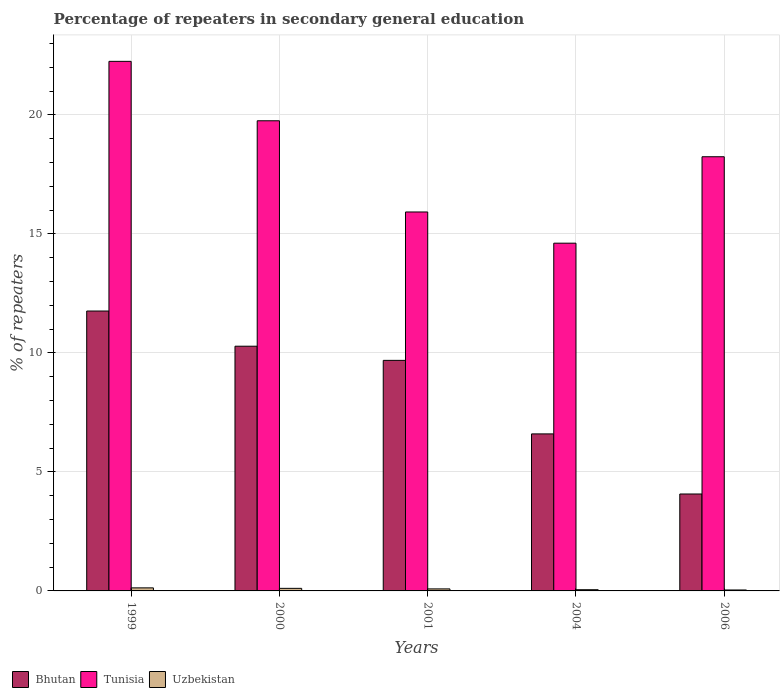Are the number of bars per tick equal to the number of legend labels?
Give a very brief answer. Yes. How many bars are there on the 2nd tick from the left?
Your response must be concise. 3. In how many cases, is the number of bars for a given year not equal to the number of legend labels?
Your response must be concise. 0. What is the percentage of repeaters in secondary general education in Uzbekistan in 2000?
Provide a succinct answer. 0.11. Across all years, what is the maximum percentage of repeaters in secondary general education in Tunisia?
Provide a short and direct response. 22.25. Across all years, what is the minimum percentage of repeaters in secondary general education in Bhutan?
Ensure brevity in your answer.  4.07. In which year was the percentage of repeaters in secondary general education in Bhutan maximum?
Provide a succinct answer. 1999. In which year was the percentage of repeaters in secondary general education in Uzbekistan minimum?
Make the answer very short. 2006. What is the total percentage of repeaters in secondary general education in Tunisia in the graph?
Provide a succinct answer. 90.77. What is the difference between the percentage of repeaters in secondary general education in Tunisia in 1999 and that in 2000?
Ensure brevity in your answer.  2.5. What is the difference between the percentage of repeaters in secondary general education in Tunisia in 2001 and the percentage of repeaters in secondary general education in Bhutan in 1999?
Provide a succinct answer. 4.16. What is the average percentage of repeaters in secondary general education in Tunisia per year?
Provide a succinct answer. 18.15. In the year 2006, what is the difference between the percentage of repeaters in secondary general education in Tunisia and percentage of repeaters in secondary general education in Bhutan?
Give a very brief answer. 14.17. In how many years, is the percentage of repeaters in secondary general education in Tunisia greater than 3 %?
Make the answer very short. 5. What is the ratio of the percentage of repeaters in secondary general education in Uzbekistan in 2001 to that in 2006?
Give a very brief answer. 2.16. Is the difference between the percentage of repeaters in secondary general education in Tunisia in 2004 and 2006 greater than the difference between the percentage of repeaters in secondary general education in Bhutan in 2004 and 2006?
Offer a terse response. No. What is the difference between the highest and the second highest percentage of repeaters in secondary general education in Tunisia?
Your answer should be compact. 2.5. What is the difference between the highest and the lowest percentage of repeaters in secondary general education in Uzbekistan?
Ensure brevity in your answer.  0.09. What does the 3rd bar from the left in 2004 represents?
Make the answer very short. Uzbekistan. What does the 1st bar from the right in 1999 represents?
Provide a short and direct response. Uzbekistan. Is it the case that in every year, the sum of the percentage of repeaters in secondary general education in Uzbekistan and percentage of repeaters in secondary general education in Bhutan is greater than the percentage of repeaters in secondary general education in Tunisia?
Offer a terse response. No. Does the graph contain any zero values?
Your answer should be compact. No. Does the graph contain grids?
Offer a very short reply. Yes. How many legend labels are there?
Offer a very short reply. 3. How are the legend labels stacked?
Give a very brief answer. Horizontal. What is the title of the graph?
Ensure brevity in your answer.  Percentage of repeaters in secondary general education. Does "Liechtenstein" appear as one of the legend labels in the graph?
Your answer should be compact. No. What is the label or title of the X-axis?
Your answer should be compact. Years. What is the label or title of the Y-axis?
Offer a very short reply. % of repeaters. What is the % of repeaters in Bhutan in 1999?
Make the answer very short. 11.76. What is the % of repeaters of Tunisia in 1999?
Make the answer very short. 22.25. What is the % of repeaters of Uzbekistan in 1999?
Make the answer very short. 0.13. What is the % of repeaters in Bhutan in 2000?
Offer a terse response. 10.28. What is the % of repeaters in Tunisia in 2000?
Ensure brevity in your answer.  19.75. What is the % of repeaters of Uzbekistan in 2000?
Your answer should be very brief. 0.11. What is the % of repeaters in Bhutan in 2001?
Your answer should be very brief. 9.69. What is the % of repeaters in Tunisia in 2001?
Offer a very short reply. 15.92. What is the % of repeaters in Uzbekistan in 2001?
Provide a short and direct response. 0.09. What is the % of repeaters of Bhutan in 2004?
Offer a very short reply. 6.6. What is the % of repeaters in Tunisia in 2004?
Offer a terse response. 14.61. What is the % of repeaters in Uzbekistan in 2004?
Your answer should be very brief. 0.05. What is the % of repeaters in Bhutan in 2006?
Your answer should be very brief. 4.07. What is the % of repeaters in Tunisia in 2006?
Make the answer very short. 18.24. What is the % of repeaters in Uzbekistan in 2006?
Your answer should be compact. 0.04. Across all years, what is the maximum % of repeaters in Bhutan?
Keep it short and to the point. 11.76. Across all years, what is the maximum % of repeaters in Tunisia?
Your response must be concise. 22.25. Across all years, what is the maximum % of repeaters in Uzbekistan?
Offer a terse response. 0.13. Across all years, what is the minimum % of repeaters in Bhutan?
Offer a terse response. 4.07. Across all years, what is the minimum % of repeaters of Tunisia?
Offer a terse response. 14.61. Across all years, what is the minimum % of repeaters of Uzbekistan?
Your answer should be very brief. 0.04. What is the total % of repeaters in Bhutan in the graph?
Your answer should be compact. 42.39. What is the total % of repeaters of Tunisia in the graph?
Offer a terse response. 90.77. What is the total % of repeaters in Uzbekistan in the graph?
Make the answer very short. 0.41. What is the difference between the % of repeaters in Bhutan in 1999 and that in 2000?
Your answer should be compact. 1.48. What is the difference between the % of repeaters in Tunisia in 1999 and that in 2000?
Ensure brevity in your answer.  2.5. What is the difference between the % of repeaters in Uzbekistan in 1999 and that in 2000?
Your answer should be very brief. 0.02. What is the difference between the % of repeaters in Bhutan in 1999 and that in 2001?
Keep it short and to the point. 2.07. What is the difference between the % of repeaters in Tunisia in 1999 and that in 2001?
Your response must be concise. 6.33. What is the difference between the % of repeaters of Uzbekistan in 1999 and that in 2001?
Make the answer very short. 0.04. What is the difference between the % of repeaters in Bhutan in 1999 and that in 2004?
Your answer should be compact. 5.16. What is the difference between the % of repeaters in Tunisia in 1999 and that in 2004?
Your answer should be very brief. 7.64. What is the difference between the % of repeaters of Uzbekistan in 1999 and that in 2004?
Ensure brevity in your answer.  0.08. What is the difference between the % of repeaters in Bhutan in 1999 and that in 2006?
Your answer should be compact. 7.69. What is the difference between the % of repeaters in Tunisia in 1999 and that in 2006?
Your answer should be compact. 4.01. What is the difference between the % of repeaters of Uzbekistan in 1999 and that in 2006?
Ensure brevity in your answer.  0.09. What is the difference between the % of repeaters in Bhutan in 2000 and that in 2001?
Your response must be concise. 0.6. What is the difference between the % of repeaters of Tunisia in 2000 and that in 2001?
Keep it short and to the point. 3.83. What is the difference between the % of repeaters in Uzbekistan in 2000 and that in 2001?
Provide a short and direct response. 0.02. What is the difference between the % of repeaters of Bhutan in 2000 and that in 2004?
Your answer should be compact. 3.68. What is the difference between the % of repeaters of Tunisia in 2000 and that in 2004?
Your answer should be very brief. 5.14. What is the difference between the % of repeaters of Uzbekistan in 2000 and that in 2004?
Your response must be concise. 0.06. What is the difference between the % of repeaters of Bhutan in 2000 and that in 2006?
Your response must be concise. 6.21. What is the difference between the % of repeaters in Tunisia in 2000 and that in 2006?
Offer a terse response. 1.51. What is the difference between the % of repeaters in Uzbekistan in 2000 and that in 2006?
Give a very brief answer. 0.07. What is the difference between the % of repeaters of Bhutan in 2001 and that in 2004?
Your response must be concise. 3.09. What is the difference between the % of repeaters of Tunisia in 2001 and that in 2004?
Ensure brevity in your answer.  1.31. What is the difference between the % of repeaters in Uzbekistan in 2001 and that in 2004?
Make the answer very short. 0.03. What is the difference between the % of repeaters of Bhutan in 2001 and that in 2006?
Offer a terse response. 5.61. What is the difference between the % of repeaters in Tunisia in 2001 and that in 2006?
Keep it short and to the point. -2.32. What is the difference between the % of repeaters of Uzbekistan in 2001 and that in 2006?
Your answer should be very brief. 0.05. What is the difference between the % of repeaters in Bhutan in 2004 and that in 2006?
Keep it short and to the point. 2.52. What is the difference between the % of repeaters in Tunisia in 2004 and that in 2006?
Provide a short and direct response. -3.63. What is the difference between the % of repeaters of Uzbekistan in 2004 and that in 2006?
Make the answer very short. 0.01. What is the difference between the % of repeaters in Bhutan in 1999 and the % of repeaters in Tunisia in 2000?
Keep it short and to the point. -7.99. What is the difference between the % of repeaters in Bhutan in 1999 and the % of repeaters in Uzbekistan in 2000?
Offer a terse response. 11.65. What is the difference between the % of repeaters in Tunisia in 1999 and the % of repeaters in Uzbekistan in 2000?
Provide a succinct answer. 22.14. What is the difference between the % of repeaters in Bhutan in 1999 and the % of repeaters in Tunisia in 2001?
Provide a short and direct response. -4.16. What is the difference between the % of repeaters of Bhutan in 1999 and the % of repeaters of Uzbekistan in 2001?
Offer a very short reply. 11.67. What is the difference between the % of repeaters of Tunisia in 1999 and the % of repeaters of Uzbekistan in 2001?
Offer a terse response. 22.16. What is the difference between the % of repeaters of Bhutan in 1999 and the % of repeaters of Tunisia in 2004?
Give a very brief answer. -2.85. What is the difference between the % of repeaters in Bhutan in 1999 and the % of repeaters in Uzbekistan in 2004?
Ensure brevity in your answer.  11.71. What is the difference between the % of repeaters in Tunisia in 1999 and the % of repeaters in Uzbekistan in 2004?
Provide a short and direct response. 22.2. What is the difference between the % of repeaters of Bhutan in 1999 and the % of repeaters of Tunisia in 2006?
Give a very brief answer. -6.48. What is the difference between the % of repeaters of Bhutan in 1999 and the % of repeaters of Uzbekistan in 2006?
Your response must be concise. 11.72. What is the difference between the % of repeaters of Tunisia in 1999 and the % of repeaters of Uzbekistan in 2006?
Ensure brevity in your answer.  22.21. What is the difference between the % of repeaters of Bhutan in 2000 and the % of repeaters of Tunisia in 2001?
Offer a terse response. -5.64. What is the difference between the % of repeaters in Bhutan in 2000 and the % of repeaters in Uzbekistan in 2001?
Make the answer very short. 10.2. What is the difference between the % of repeaters in Tunisia in 2000 and the % of repeaters in Uzbekistan in 2001?
Offer a terse response. 19.67. What is the difference between the % of repeaters in Bhutan in 2000 and the % of repeaters in Tunisia in 2004?
Give a very brief answer. -4.33. What is the difference between the % of repeaters of Bhutan in 2000 and the % of repeaters of Uzbekistan in 2004?
Offer a very short reply. 10.23. What is the difference between the % of repeaters of Tunisia in 2000 and the % of repeaters of Uzbekistan in 2004?
Offer a very short reply. 19.7. What is the difference between the % of repeaters in Bhutan in 2000 and the % of repeaters in Tunisia in 2006?
Your answer should be very brief. -7.96. What is the difference between the % of repeaters in Bhutan in 2000 and the % of repeaters in Uzbekistan in 2006?
Ensure brevity in your answer.  10.24. What is the difference between the % of repeaters of Tunisia in 2000 and the % of repeaters of Uzbekistan in 2006?
Ensure brevity in your answer.  19.71. What is the difference between the % of repeaters in Bhutan in 2001 and the % of repeaters in Tunisia in 2004?
Provide a succinct answer. -4.92. What is the difference between the % of repeaters of Bhutan in 2001 and the % of repeaters of Uzbekistan in 2004?
Keep it short and to the point. 9.63. What is the difference between the % of repeaters of Tunisia in 2001 and the % of repeaters of Uzbekistan in 2004?
Your answer should be very brief. 15.87. What is the difference between the % of repeaters in Bhutan in 2001 and the % of repeaters in Tunisia in 2006?
Ensure brevity in your answer.  -8.55. What is the difference between the % of repeaters of Bhutan in 2001 and the % of repeaters of Uzbekistan in 2006?
Make the answer very short. 9.65. What is the difference between the % of repeaters of Tunisia in 2001 and the % of repeaters of Uzbekistan in 2006?
Your answer should be compact. 15.88. What is the difference between the % of repeaters of Bhutan in 2004 and the % of repeaters of Tunisia in 2006?
Provide a succinct answer. -11.64. What is the difference between the % of repeaters of Bhutan in 2004 and the % of repeaters of Uzbekistan in 2006?
Your response must be concise. 6.56. What is the difference between the % of repeaters in Tunisia in 2004 and the % of repeaters in Uzbekistan in 2006?
Keep it short and to the point. 14.57. What is the average % of repeaters of Bhutan per year?
Give a very brief answer. 8.48. What is the average % of repeaters in Tunisia per year?
Provide a succinct answer. 18.15. What is the average % of repeaters of Uzbekistan per year?
Give a very brief answer. 0.08. In the year 1999, what is the difference between the % of repeaters in Bhutan and % of repeaters in Tunisia?
Your answer should be very brief. -10.49. In the year 1999, what is the difference between the % of repeaters in Bhutan and % of repeaters in Uzbekistan?
Offer a terse response. 11.63. In the year 1999, what is the difference between the % of repeaters in Tunisia and % of repeaters in Uzbekistan?
Provide a succinct answer. 22.12. In the year 2000, what is the difference between the % of repeaters of Bhutan and % of repeaters of Tunisia?
Your response must be concise. -9.47. In the year 2000, what is the difference between the % of repeaters of Bhutan and % of repeaters of Uzbekistan?
Your answer should be compact. 10.17. In the year 2000, what is the difference between the % of repeaters in Tunisia and % of repeaters in Uzbekistan?
Your response must be concise. 19.64. In the year 2001, what is the difference between the % of repeaters in Bhutan and % of repeaters in Tunisia?
Give a very brief answer. -6.23. In the year 2001, what is the difference between the % of repeaters of Bhutan and % of repeaters of Uzbekistan?
Keep it short and to the point. 9.6. In the year 2001, what is the difference between the % of repeaters of Tunisia and % of repeaters of Uzbekistan?
Provide a succinct answer. 15.83. In the year 2004, what is the difference between the % of repeaters in Bhutan and % of repeaters in Tunisia?
Offer a very short reply. -8.01. In the year 2004, what is the difference between the % of repeaters of Bhutan and % of repeaters of Uzbekistan?
Your answer should be compact. 6.55. In the year 2004, what is the difference between the % of repeaters of Tunisia and % of repeaters of Uzbekistan?
Your answer should be very brief. 14.56. In the year 2006, what is the difference between the % of repeaters of Bhutan and % of repeaters of Tunisia?
Your response must be concise. -14.17. In the year 2006, what is the difference between the % of repeaters in Bhutan and % of repeaters in Uzbekistan?
Your answer should be compact. 4.03. In the year 2006, what is the difference between the % of repeaters in Tunisia and % of repeaters in Uzbekistan?
Your response must be concise. 18.2. What is the ratio of the % of repeaters of Bhutan in 1999 to that in 2000?
Make the answer very short. 1.14. What is the ratio of the % of repeaters of Tunisia in 1999 to that in 2000?
Offer a very short reply. 1.13. What is the ratio of the % of repeaters of Uzbekistan in 1999 to that in 2000?
Keep it short and to the point. 1.18. What is the ratio of the % of repeaters in Bhutan in 1999 to that in 2001?
Your response must be concise. 1.21. What is the ratio of the % of repeaters in Tunisia in 1999 to that in 2001?
Ensure brevity in your answer.  1.4. What is the ratio of the % of repeaters of Uzbekistan in 1999 to that in 2001?
Offer a terse response. 1.5. What is the ratio of the % of repeaters of Bhutan in 1999 to that in 2004?
Ensure brevity in your answer.  1.78. What is the ratio of the % of repeaters in Tunisia in 1999 to that in 2004?
Provide a succinct answer. 1.52. What is the ratio of the % of repeaters of Uzbekistan in 1999 to that in 2004?
Provide a succinct answer. 2.51. What is the ratio of the % of repeaters in Bhutan in 1999 to that in 2006?
Keep it short and to the point. 2.89. What is the ratio of the % of repeaters in Tunisia in 1999 to that in 2006?
Provide a succinct answer. 1.22. What is the ratio of the % of repeaters in Uzbekistan in 1999 to that in 2006?
Your answer should be compact. 3.25. What is the ratio of the % of repeaters of Bhutan in 2000 to that in 2001?
Your answer should be compact. 1.06. What is the ratio of the % of repeaters in Tunisia in 2000 to that in 2001?
Your answer should be very brief. 1.24. What is the ratio of the % of repeaters in Uzbekistan in 2000 to that in 2001?
Make the answer very short. 1.27. What is the ratio of the % of repeaters of Bhutan in 2000 to that in 2004?
Provide a short and direct response. 1.56. What is the ratio of the % of repeaters in Tunisia in 2000 to that in 2004?
Your response must be concise. 1.35. What is the ratio of the % of repeaters in Uzbekistan in 2000 to that in 2004?
Your answer should be very brief. 2.12. What is the ratio of the % of repeaters of Bhutan in 2000 to that in 2006?
Give a very brief answer. 2.52. What is the ratio of the % of repeaters in Tunisia in 2000 to that in 2006?
Provide a succinct answer. 1.08. What is the ratio of the % of repeaters in Uzbekistan in 2000 to that in 2006?
Make the answer very short. 2.74. What is the ratio of the % of repeaters of Bhutan in 2001 to that in 2004?
Provide a succinct answer. 1.47. What is the ratio of the % of repeaters in Tunisia in 2001 to that in 2004?
Provide a short and direct response. 1.09. What is the ratio of the % of repeaters of Uzbekistan in 2001 to that in 2004?
Your response must be concise. 1.67. What is the ratio of the % of repeaters of Bhutan in 2001 to that in 2006?
Your answer should be very brief. 2.38. What is the ratio of the % of repeaters in Tunisia in 2001 to that in 2006?
Provide a succinct answer. 0.87. What is the ratio of the % of repeaters of Uzbekistan in 2001 to that in 2006?
Provide a short and direct response. 2.16. What is the ratio of the % of repeaters in Bhutan in 2004 to that in 2006?
Your response must be concise. 1.62. What is the ratio of the % of repeaters in Tunisia in 2004 to that in 2006?
Provide a succinct answer. 0.8. What is the ratio of the % of repeaters in Uzbekistan in 2004 to that in 2006?
Offer a terse response. 1.29. What is the difference between the highest and the second highest % of repeaters of Bhutan?
Your answer should be compact. 1.48. What is the difference between the highest and the second highest % of repeaters in Tunisia?
Ensure brevity in your answer.  2.5. What is the difference between the highest and the second highest % of repeaters of Uzbekistan?
Offer a very short reply. 0.02. What is the difference between the highest and the lowest % of repeaters in Bhutan?
Ensure brevity in your answer.  7.69. What is the difference between the highest and the lowest % of repeaters in Tunisia?
Give a very brief answer. 7.64. What is the difference between the highest and the lowest % of repeaters in Uzbekistan?
Keep it short and to the point. 0.09. 